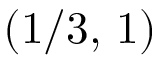Convert formula to latex. <formula><loc_0><loc_0><loc_500><loc_500>( 1 / 3 , \, 1 )</formula> 